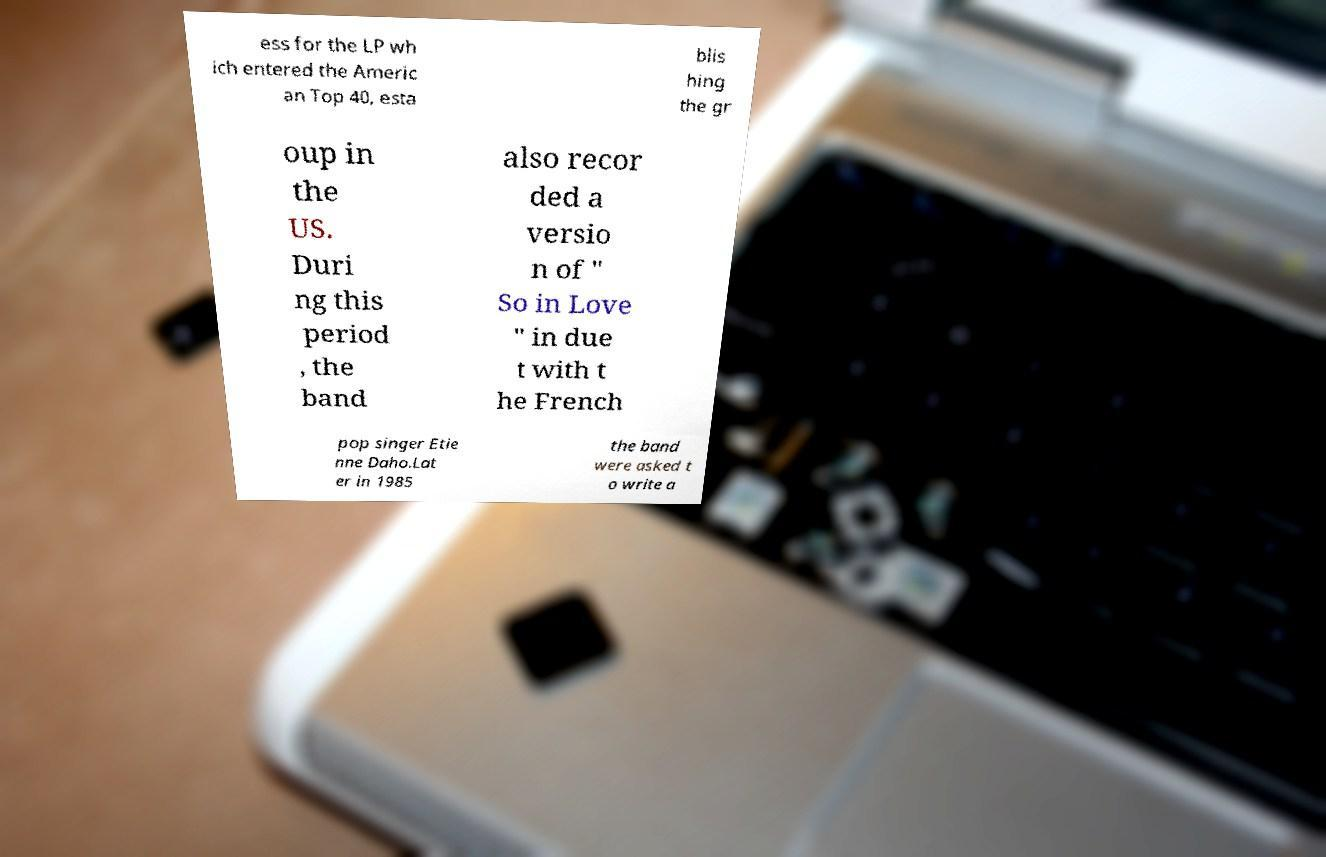For documentation purposes, I need the text within this image transcribed. Could you provide that? ess for the LP wh ich entered the Americ an Top 40, esta blis hing the gr oup in the US. Duri ng this period , the band also recor ded a versio n of " So in Love " in due t with t he French pop singer Etie nne Daho.Lat er in 1985 the band were asked t o write a 